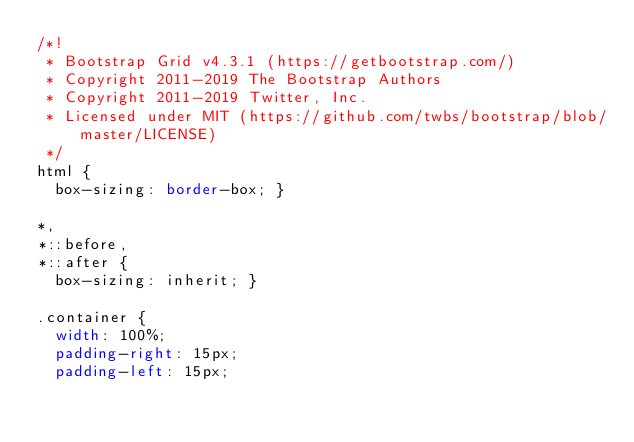Convert code to text. <code><loc_0><loc_0><loc_500><loc_500><_CSS_>/*!
 * Bootstrap Grid v4.3.1 (https://getbootstrap.com/)
 * Copyright 2011-2019 The Bootstrap Authors
 * Copyright 2011-2019 Twitter, Inc.
 * Licensed under MIT (https://github.com/twbs/bootstrap/blob/master/LICENSE)
 */
html {
  box-sizing: border-box; }

*,
*::before,
*::after {
  box-sizing: inherit; }

.container {
  width: 100%;
  padding-right: 15px;
  padding-left: 15px;</code> 